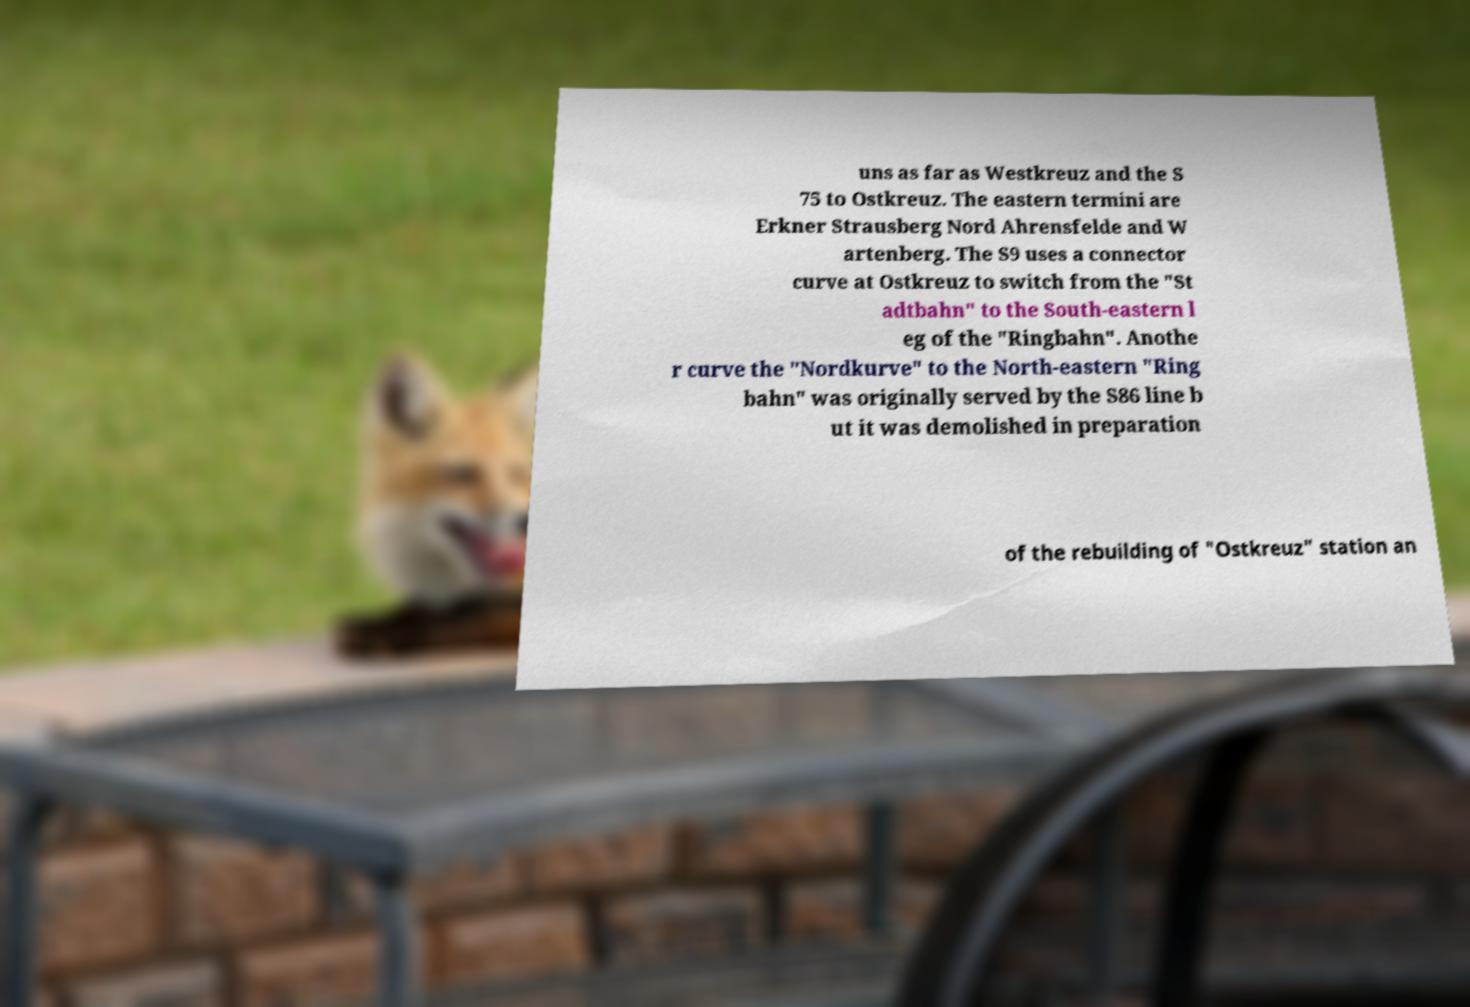Can you read and provide the text displayed in the image?This photo seems to have some interesting text. Can you extract and type it out for me? uns as far as Westkreuz and the S 75 to Ostkreuz. The eastern termini are Erkner Strausberg Nord Ahrensfelde and W artenberg. The S9 uses a connector curve at Ostkreuz to switch from the "St adtbahn" to the South-eastern l eg of the "Ringbahn". Anothe r curve the "Nordkurve" to the North-eastern "Ring bahn" was originally served by the S86 line b ut it was demolished in preparation of the rebuilding of "Ostkreuz" station an 